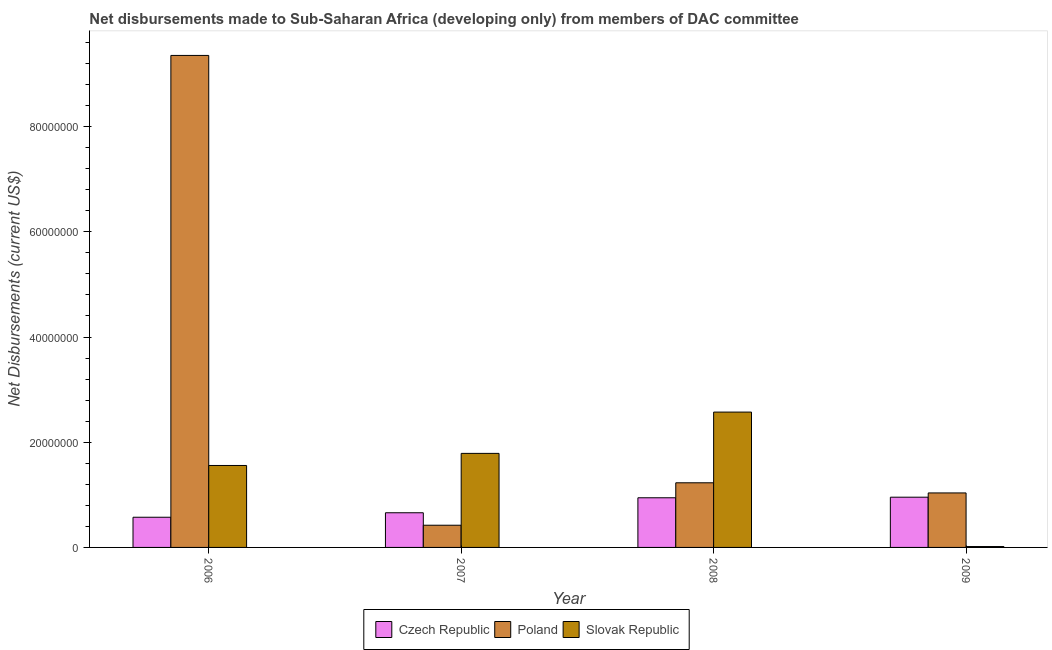How many different coloured bars are there?
Offer a terse response. 3. How many groups of bars are there?
Give a very brief answer. 4. Are the number of bars per tick equal to the number of legend labels?
Your answer should be very brief. Yes. Are the number of bars on each tick of the X-axis equal?
Offer a very short reply. Yes. How many bars are there on the 2nd tick from the left?
Provide a short and direct response. 3. How many bars are there on the 1st tick from the right?
Offer a terse response. 3. What is the label of the 3rd group of bars from the left?
Offer a terse response. 2008. What is the net disbursements made by slovak republic in 2008?
Ensure brevity in your answer.  2.57e+07. Across all years, what is the maximum net disbursements made by poland?
Provide a short and direct response. 9.35e+07. Across all years, what is the minimum net disbursements made by czech republic?
Provide a succinct answer. 5.74e+06. In which year was the net disbursements made by czech republic maximum?
Your answer should be very brief. 2009. What is the total net disbursements made by slovak republic in the graph?
Ensure brevity in your answer.  5.94e+07. What is the difference between the net disbursements made by czech republic in 2008 and that in 2009?
Give a very brief answer. -1.10e+05. What is the difference between the net disbursements made by czech republic in 2006 and the net disbursements made by slovak republic in 2008?
Give a very brief answer. -3.70e+06. What is the average net disbursements made by slovak republic per year?
Your answer should be very brief. 1.48e+07. What is the ratio of the net disbursements made by czech republic in 2008 to that in 2009?
Ensure brevity in your answer.  0.99. Is the net disbursements made by poland in 2006 less than that in 2007?
Keep it short and to the point. No. Is the difference between the net disbursements made by czech republic in 2007 and 2008 greater than the difference between the net disbursements made by slovak republic in 2007 and 2008?
Keep it short and to the point. No. What is the difference between the highest and the second highest net disbursements made by poland?
Ensure brevity in your answer.  8.12e+07. What is the difference between the highest and the lowest net disbursements made by czech republic?
Make the answer very short. 3.81e+06. Is the sum of the net disbursements made by slovak republic in 2006 and 2007 greater than the maximum net disbursements made by poland across all years?
Provide a short and direct response. Yes. What does the 1st bar from the right in 2009 represents?
Give a very brief answer. Slovak Republic. Is it the case that in every year, the sum of the net disbursements made by czech republic and net disbursements made by poland is greater than the net disbursements made by slovak republic?
Ensure brevity in your answer.  No. Are all the bars in the graph horizontal?
Offer a very short reply. No. How many years are there in the graph?
Ensure brevity in your answer.  4. Are the values on the major ticks of Y-axis written in scientific E-notation?
Keep it short and to the point. No. Does the graph contain any zero values?
Your answer should be compact. No. Does the graph contain grids?
Your response must be concise. No. Where does the legend appear in the graph?
Your answer should be compact. Bottom center. How many legend labels are there?
Make the answer very short. 3. What is the title of the graph?
Offer a very short reply. Net disbursements made to Sub-Saharan Africa (developing only) from members of DAC committee. Does "Taxes on goods and services" appear as one of the legend labels in the graph?
Provide a short and direct response. No. What is the label or title of the Y-axis?
Offer a terse response. Net Disbursements (current US$). What is the Net Disbursements (current US$) of Czech Republic in 2006?
Provide a short and direct response. 5.74e+06. What is the Net Disbursements (current US$) in Poland in 2006?
Offer a terse response. 9.35e+07. What is the Net Disbursements (current US$) in Slovak Republic in 2006?
Provide a succinct answer. 1.56e+07. What is the Net Disbursements (current US$) in Czech Republic in 2007?
Make the answer very short. 6.59e+06. What is the Net Disbursements (current US$) of Poland in 2007?
Keep it short and to the point. 4.22e+06. What is the Net Disbursements (current US$) in Slovak Republic in 2007?
Provide a succinct answer. 1.79e+07. What is the Net Disbursements (current US$) in Czech Republic in 2008?
Provide a succinct answer. 9.44e+06. What is the Net Disbursements (current US$) in Poland in 2008?
Make the answer very short. 1.23e+07. What is the Net Disbursements (current US$) of Slovak Republic in 2008?
Your answer should be compact. 2.57e+07. What is the Net Disbursements (current US$) in Czech Republic in 2009?
Your answer should be very brief. 9.55e+06. What is the Net Disbursements (current US$) of Poland in 2009?
Your answer should be compact. 1.04e+07. What is the Net Disbursements (current US$) of Slovak Republic in 2009?
Provide a succinct answer. 1.70e+05. Across all years, what is the maximum Net Disbursements (current US$) in Czech Republic?
Your response must be concise. 9.55e+06. Across all years, what is the maximum Net Disbursements (current US$) of Poland?
Provide a short and direct response. 9.35e+07. Across all years, what is the maximum Net Disbursements (current US$) in Slovak Republic?
Make the answer very short. 2.57e+07. Across all years, what is the minimum Net Disbursements (current US$) of Czech Republic?
Ensure brevity in your answer.  5.74e+06. Across all years, what is the minimum Net Disbursements (current US$) of Poland?
Keep it short and to the point. 4.22e+06. Across all years, what is the minimum Net Disbursements (current US$) in Slovak Republic?
Offer a terse response. 1.70e+05. What is the total Net Disbursements (current US$) of Czech Republic in the graph?
Provide a short and direct response. 3.13e+07. What is the total Net Disbursements (current US$) of Poland in the graph?
Keep it short and to the point. 1.20e+08. What is the total Net Disbursements (current US$) of Slovak Republic in the graph?
Offer a terse response. 5.94e+07. What is the difference between the Net Disbursements (current US$) in Czech Republic in 2006 and that in 2007?
Your response must be concise. -8.50e+05. What is the difference between the Net Disbursements (current US$) of Poland in 2006 and that in 2007?
Keep it short and to the point. 8.93e+07. What is the difference between the Net Disbursements (current US$) in Slovak Republic in 2006 and that in 2007?
Ensure brevity in your answer.  -2.30e+06. What is the difference between the Net Disbursements (current US$) of Czech Republic in 2006 and that in 2008?
Keep it short and to the point. -3.70e+06. What is the difference between the Net Disbursements (current US$) of Poland in 2006 and that in 2008?
Offer a terse response. 8.12e+07. What is the difference between the Net Disbursements (current US$) in Slovak Republic in 2006 and that in 2008?
Keep it short and to the point. -1.02e+07. What is the difference between the Net Disbursements (current US$) of Czech Republic in 2006 and that in 2009?
Keep it short and to the point. -3.81e+06. What is the difference between the Net Disbursements (current US$) of Poland in 2006 and that in 2009?
Your response must be concise. 8.32e+07. What is the difference between the Net Disbursements (current US$) of Slovak Republic in 2006 and that in 2009?
Ensure brevity in your answer.  1.54e+07. What is the difference between the Net Disbursements (current US$) of Czech Republic in 2007 and that in 2008?
Give a very brief answer. -2.85e+06. What is the difference between the Net Disbursements (current US$) of Poland in 2007 and that in 2008?
Make the answer very short. -8.07e+06. What is the difference between the Net Disbursements (current US$) of Slovak Republic in 2007 and that in 2008?
Offer a terse response. -7.85e+06. What is the difference between the Net Disbursements (current US$) of Czech Republic in 2007 and that in 2009?
Offer a very short reply. -2.96e+06. What is the difference between the Net Disbursements (current US$) of Poland in 2007 and that in 2009?
Offer a very short reply. -6.14e+06. What is the difference between the Net Disbursements (current US$) in Slovak Republic in 2007 and that in 2009?
Your answer should be very brief. 1.77e+07. What is the difference between the Net Disbursements (current US$) in Poland in 2008 and that in 2009?
Your answer should be compact. 1.93e+06. What is the difference between the Net Disbursements (current US$) in Slovak Republic in 2008 and that in 2009?
Offer a very short reply. 2.56e+07. What is the difference between the Net Disbursements (current US$) of Czech Republic in 2006 and the Net Disbursements (current US$) of Poland in 2007?
Give a very brief answer. 1.52e+06. What is the difference between the Net Disbursements (current US$) of Czech Republic in 2006 and the Net Disbursements (current US$) of Slovak Republic in 2007?
Your response must be concise. -1.21e+07. What is the difference between the Net Disbursements (current US$) in Poland in 2006 and the Net Disbursements (current US$) in Slovak Republic in 2007?
Provide a succinct answer. 7.57e+07. What is the difference between the Net Disbursements (current US$) in Czech Republic in 2006 and the Net Disbursements (current US$) in Poland in 2008?
Ensure brevity in your answer.  -6.55e+06. What is the difference between the Net Disbursements (current US$) of Czech Republic in 2006 and the Net Disbursements (current US$) of Slovak Republic in 2008?
Your answer should be very brief. -2.00e+07. What is the difference between the Net Disbursements (current US$) in Poland in 2006 and the Net Disbursements (current US$) in Slovak Republic in 2008?
Your answer should be very brief. 6.78e+07. What is the difference between the Net Disbursements (current US$) of Czech Republic in 2006 and the Net Disbursements (current US$) of Poland in 2009?
Your answer should be compact. -4.62e+06. What is the difference between the Net Disbursements (current US$) in Czech Republic in 2006 and the Net Disbursements (current US$) in Slovak Republic in 2009?
Provide a short and direct response. 5.57e+06. What is the difference between the Net Disbursements (current US$) in Poland in 2006 and the Net Disbursements (current US$) in Slovak Republic in 2009?
Make the answer very short. 9.34e+07. What is the difference between the Net Disbursements (current US$) in Czech Republic in 2007 and the Net Disbursements (current US$) in Poland in 2008?
Make the answer very short. -5.70e+06. What is the difference between the Net Disbursements (current US$) in Czech Republic in 2007 and the Net Disbursements (current US$) in Slovak Republic in 2008?
Your answer should be very brief. -1.91e+07. What is the difference between the Net Disbursements (current US$) of Poland in 2007 and the Net Disbursements (current US$) of Slovak Republic in 2008?
Give a very brief answer. -2.15e+07. What is the difference between the Net Disbursements (current US$) in Czech Republic in 2007 and the Net Disbursements (current US$) in Poland in 2009?
Your answer should be very brief. -3.77e+06. What is the difference between the Net Disbursements (current US$) in Czech Republic in 2007 and the Net Disbursements (current US$) in Slovak Republic in 2009?
Your answer should be compact. 6.42e+06. What is the difference between the Net Disbursements (current US$) of Poland in 2007 and the Net Disbursements (current US$) of Slovak Republic in 2009?
Your response must be concise. 4.05e+06. What is the difference between the Net Disbursements (current US$) of Czech Republic in 2008 and the Net Disbursements (current US$) of Poland in 2009?
Your answer should be very brief. -9.20e+05. What is the difference between the Net Disbursements (current US$) in Czech Republic in 2008 and the Net Disbursements (current US$) in Slovak Republic in 2009?
Provide a short and direct response. 9.27e+06. What is the difference between the Net Disbursements (current US$) in Poland in 2008 and the Net Disbursements (current US$) in Slovak Republic in 2009?
Keep it short and to the point. 1.21e+07. What is the average Net Disbursements (current US$) of Czech Republic per year?
Offer a terse response. 7.83e+06. What is the average Net Disbursements (current US$) of Poland per year?
Make the answer very short. 3.01e+07. What is the average Net Disbursements (current US$) in Slovak Republic per year?
Ensure brevity in your answer.  1.48e+07. In the year 2006, what is the difference between the Net Disbursements (current US$) of Czech Republic and Net Disbursements (current US$) of Poland?
Make the answer very short. -8.78e+07. In the year 2006, what is the difference between the Net Disbursements (current US$) of Czech Republic and Net Disbursements (current US$) of Slovak Republic?
Your response must be concise. -9.84e+06. In the year 2006, what is the difference between the Net Disbursements (current US$) of Poland and Net Disbursements (current US$) of Slovak Republic?
Offer a terse response. 7.80e+07. In the year 2007, what is the difference between the Net Disbursements (current US$) in Czech Republic and Net Disbursements (current US$) in Poland?
Your response must be concise. 2.37e+06. In the year 2007, what is the difference between the Net Disbursements (current US$) in Czech Republic and Net Disbursements (current US$) in Slovak Republic?
Offer a very short reply. -1.13e+07. In the year 2007, what is the difference between the Net Disbursements (current US$) of Poland and Net Disbursements (current US$) of Slovak Republic?
Your answer should be very brief. -1.37e+07. In the year 2008, what is the difference between the Net Disbursements (current US$) of Czech Republic and Net Disbursements (current US$) of Poland?
Your response must be concise. -2.85e+06. In the year 2008, what is the difference between the Net Disbursements (current US$) in Czech Republic and Net Disbursements (current US$) in Slovak Republic?
Ensure brevity in your answer.  -1.63e+07. In the year 2008, what is the difference between the Net Disbursements (current US$) of Poland and Net Disbursements (current US$) of Slovak Republic?
Your answer should be very brief. -1.34e+07. In the year 2009, what is the difference between the Net Disbursements (current US$) in Czech Republic and Net Disbursements (current US$) in Poland?
Provide a short and direct response. -8.10e+05. In the year 2009, what is the difference between the Net Disbursements (current US$) in Czech Republic and Net Disbursements (current US$) in Slovak Republic?
Your answer should be compact. 9.38e+06. In the year 2009, what is the difference between the Net Disbursements (current US$) in Poland and Net Disbursements (current US$) in Slovak Republic?
Provide a short and direct response. 1.02e+07. What is the ratio of the Net Disbursements (current US$) of Czech Republic in 2006 to that in 2007?
Your answer should be compact. 0.87. What is the ratio of the Net Disbursements (current US$) in Poland in 2006 to that in 2007?
Your response must be concise. 22.17. What is the ratio of the Net Disbursements (current US$) of Slovak Republic in 2006 to that in 2007?
Your answer should be very brief. 0.87. What is the ratio of the Net Disbursements (current US$) of Czech Republic in 2006 to that in 2008?
Make the answer very short. 0.61. What is the ratio of the Net Disbursements (current US$) in Poland in 2006 to that in 2008?
Give a very brief answer. 7.61. What is the ratio of the Net Disbursements (current US$) in Slovak Republic in 2006 to that in 2008?
Give a very brief answer. 0.61. What is the ratio of the Net Disbursements (current US$) in Czech Republic in 2006 to that in 2009?
Ensure brevity in your answer.  0.6. What is the ratio of the Net Disbursements (current US$) of Poland in 2006 to that in 2009?
Make the answer very short. 9.03. What is the ratio of the Net Disbursements (current US$) in Slovak Republic in 2006 to that in 2009?
Provide a short and direct response. 91.65. What is the ratio of the Net Disbursements (current US$) of Czech Republic in 2007 to that in 2008?
Give a very brief answer. 0.7. What is the ratio of the Net Disbursements (current US$) in Poland in 2007 to that in 2008?
Provide a short and direct response. 0.34. What is the ratio of the Net Disbursements (current US$) in Slovak Republic in 2007 to that in 2008?
Your answer should be very brief. 0.69. What is the ratio of the Net Disbursements (current US$) of Czech Republic in 2007 to that in 2009?
Keep it short and to the point. 0.69. What is the ratio of the Net Disbursements (current US$) in Poland in 2007 to that in 2009?
Your answer should be very brief. 0.41. What is the ratio of the Net Disbursements (current US$) of Slovak Republic in 2007 to that in 2009?
Keep it short and to the point. 105.18. What is the ratio of the Net Disbursements (current US$) in Czech Republic in 2008 to that in 2009?
Offer a very short reply. 0.99. What is the ratio of the Net Disbursements (current US$) in Poland in 2008 to that in 2009?
Offer a very short reply. 1.19. What is the ratio of the Net Disbursements (current US$) of Slovak Republic in 2008 to that in 2009?
Keep it short and to the point. 151.35. What is the difference between the highest and the second highest Net Disbursements (current US$) of Czech Republic?
Provide a succinct answer. 1.10e+05. What is the difference between the highest and the second highest Net Disbursements (current US$) of Poland?
Your answer should be compact. 8.12e+07. What is the difference between the highest and the second highest Net Disbursements (current US$) in Slovak Republic?
Make the answer very short. 7.85e+06. What is the difference between the highest and the lowest Net Disbursements (current US$) in Czech Republic?
Make the answer very short. 3.81e+06. What is the difference between the highest and the lowest Net Disbursements (current US$) in Poland?
Offer a very short reply. 8.93e+07. What is the difference between the highest and the lowest Net Disbursements (current US$) in Slovak Republic?
Provide a succinct answer. 2.56e+07. 